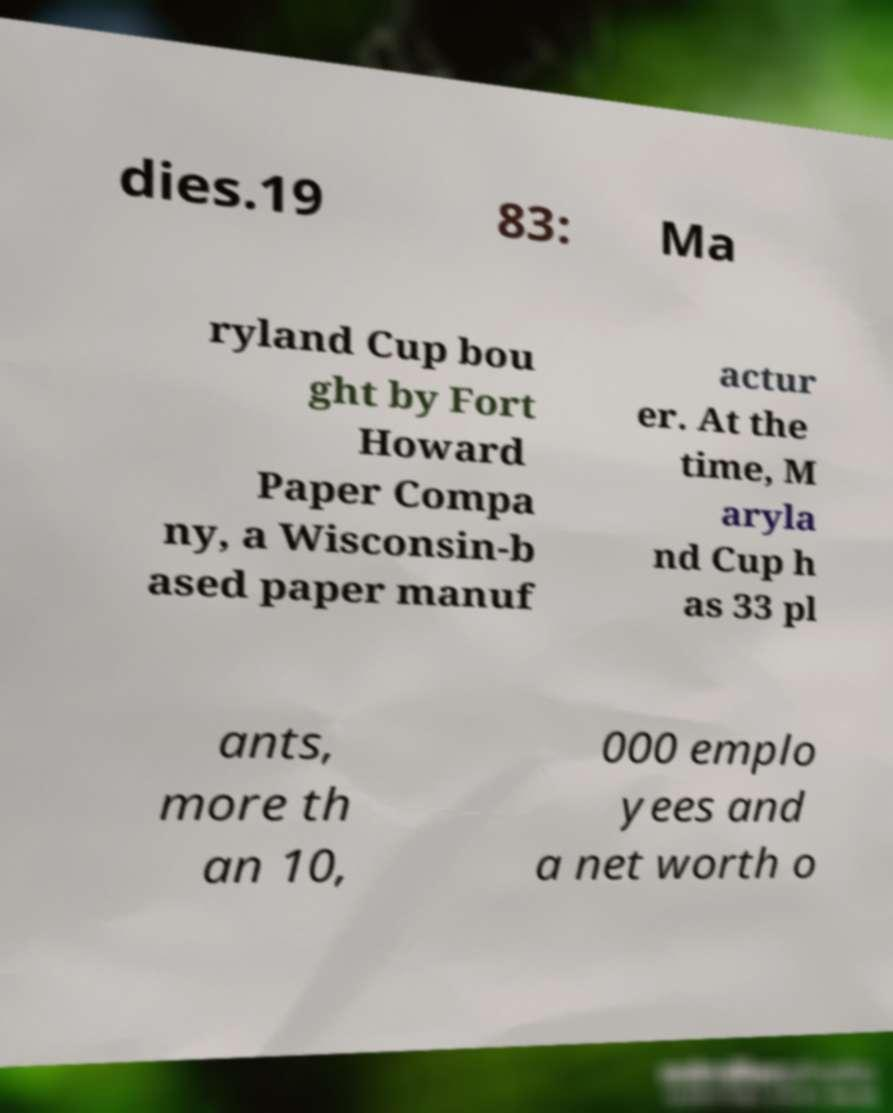Can you read and provide the text displayed in the image?This photo seems to have some interesting text. Can you extract and type it out for me? dies.19 83: Ma ryland Cup bou ght by Fort Howard Paper Compa ny, a Wisconsin-b ased paper manuf actur er. At the time, M aryla nd Cup h as 33 pl ants, more th an 10, 000 emplo yees and a net worth o 